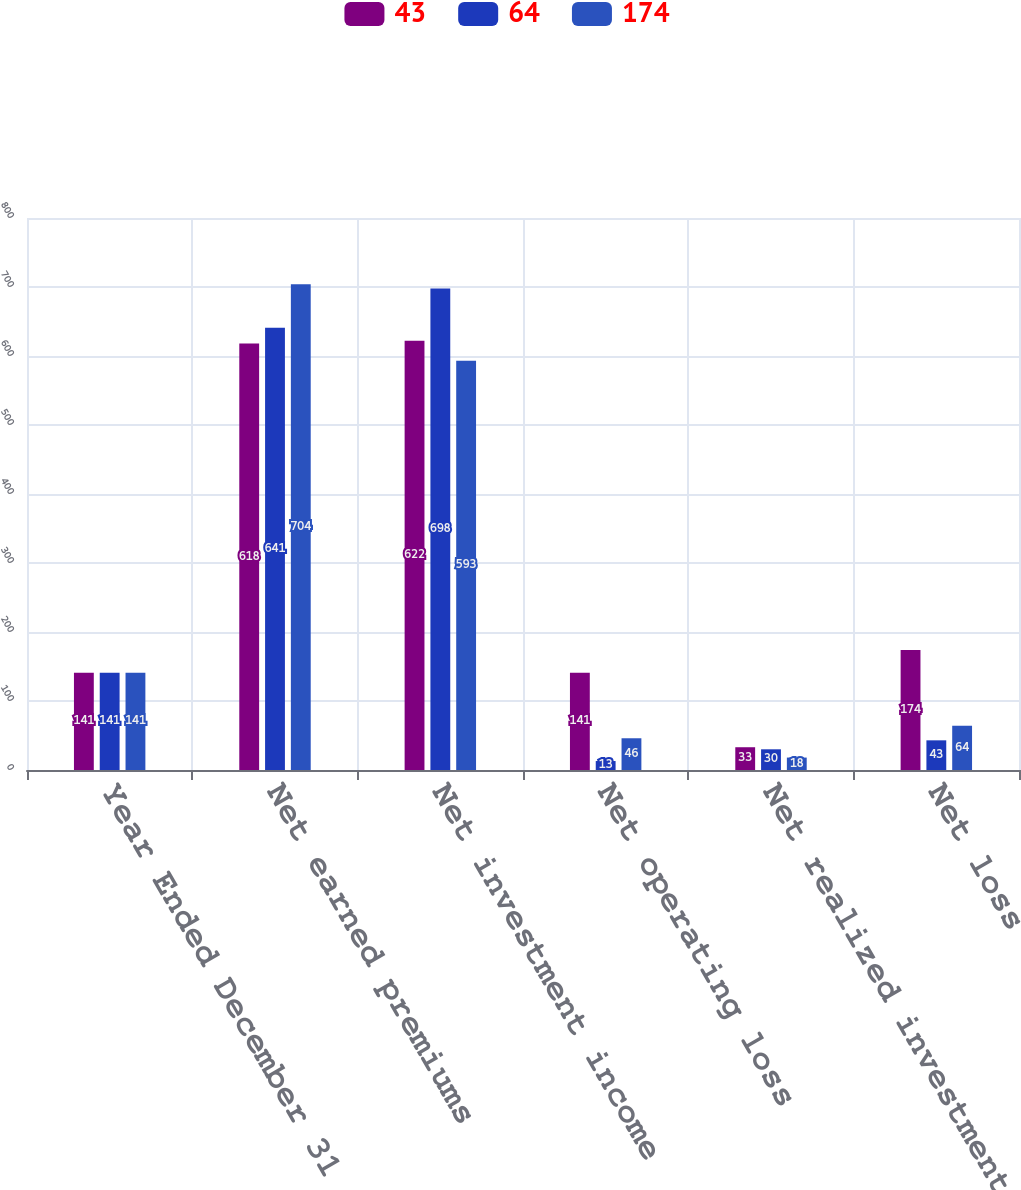<chart> <loc_0><loc_0><loc_500><loc_500><stacked_bar_chart><ecel><fcel>Year Ended December 31<fcel>Net earned premiums<fcel>Net investment income<fcel>Net operating loss<fcel>Net realized investment losses<fcel>Net loss<nl><fcel>43<fcel>141<fcel>618<fcel>622<fcel>141<fcel>33<fcel>174<nl><fcel>64<fcel>141<fcel>641<fcel>698<fcel>13<fcel>30<fcel>43<nl><fcel>174<fcel>141<fcel>704<fcel>593<fcel>46<fcel>18<fcel>64<nl></chart> 